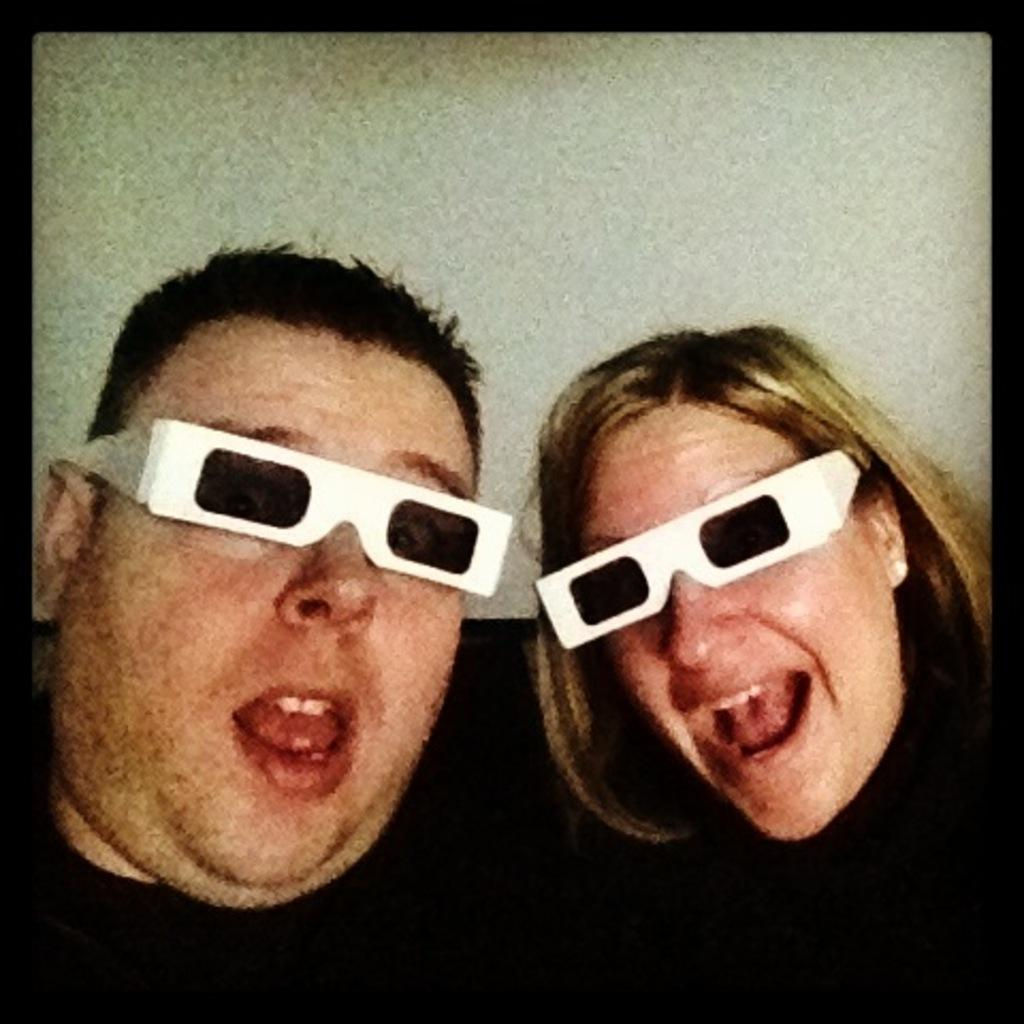What is the appearance of the man in the image? The man in the image is wearing black clothes and goggles. What is the appearance of the woman in the image? The woman in the image is also wearing black clothes and goggles. What might the man and woman be doing, given their attire? They might be engaging in an activity that requires protective eyewear, such as a sport or a science experiment. What type of truck is parked behind the man and woman in the image? There is no truck visible in the image; it only features the man and woman wearing black clothes and goggles. 